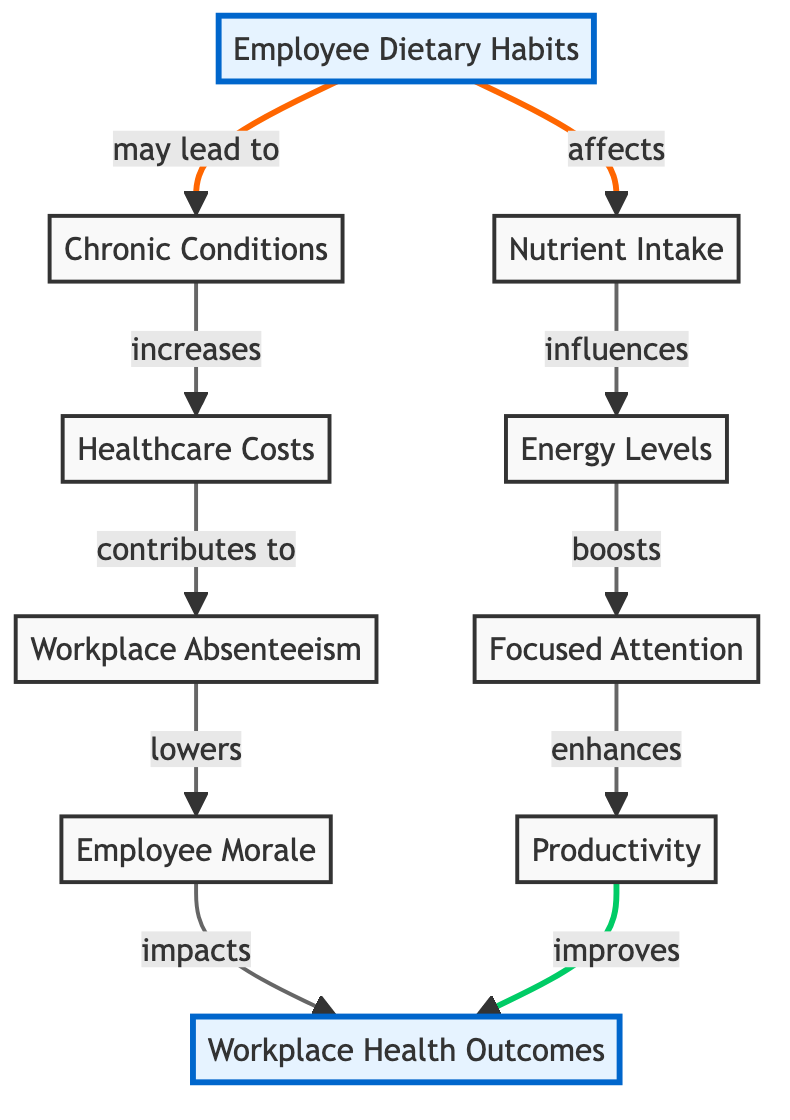What is the main focus of the diagram? The diagram primarily centers around the impact of "Employee Dietary Habits" on various "Workplace Health Outcomes". This node stands out as the central theme, indicated by its emphasize class.
Answer: Employee Dietary Habits How many total nodes are present in the diagram? Upon counting the distinct nodes in the diagram, we identify 8 unique elements, listed as employee dietary habits, nutrient intake, energy levels, focused attention, productivity, chronic conditions, healthcare costs, workplace absenteeism, employee morale, and workplace health outcomes.
Answer: 8 What relationship does nutrient intake have with energy levels? The relationship shown in the diagram states that nutrient intake influences energy levels, indicating that the amount and type of nutrients consumed can have a direct effect on the energy levels of employees.
Answer: influences Which node is affected by chronic conditions? The diagram shows that chronic conditions lead to increased healthcare costs, which impacts workplace absenteeism. This indicates that chronic conditions directly influence healthcare costs first, before their impact on absenteeism.
Answer: healthcare costs What effect does productvity have on workplace health outcomes? According to the diagram, productivity directly improves workplace health outcomes, demonstrating the positive influence that higher productivity can have on overall health at the workplace.
Answer: improves How does employee morale relate to workplace absenteeism? The diagram outlines a causal relationship wherein workplace absenteeism lowers employee morale, showing a negative impact on morale that results from increased absenteeism.
Answer: lowers What is the final effect of focused attention in the sequence? Focused attention enhances productivity, which subsequently is shown to improve workplace health outcomes, indicating its significant role in the flow towards better health outcomes in the workplace.
Answer: enhances What specific type of diagram is this? The structure and content of the diagram denote it as a Social Science Diagram, focusing on the relationships and impacts concerning employee dietary habits and health outcomes within a workplace context.
Answer: Social Science Diagram How does employee dietary habits indirectly affect workplace absenteeism? Employee dietary habits may lead to chronic conditions, which subsequently increases healthcare costs. Heightened healthcare costs contribute to workplace absenteeism, demonstrating an indirect yet significant pathway from dietary habits to absenteeism.
Answer: indirectly 